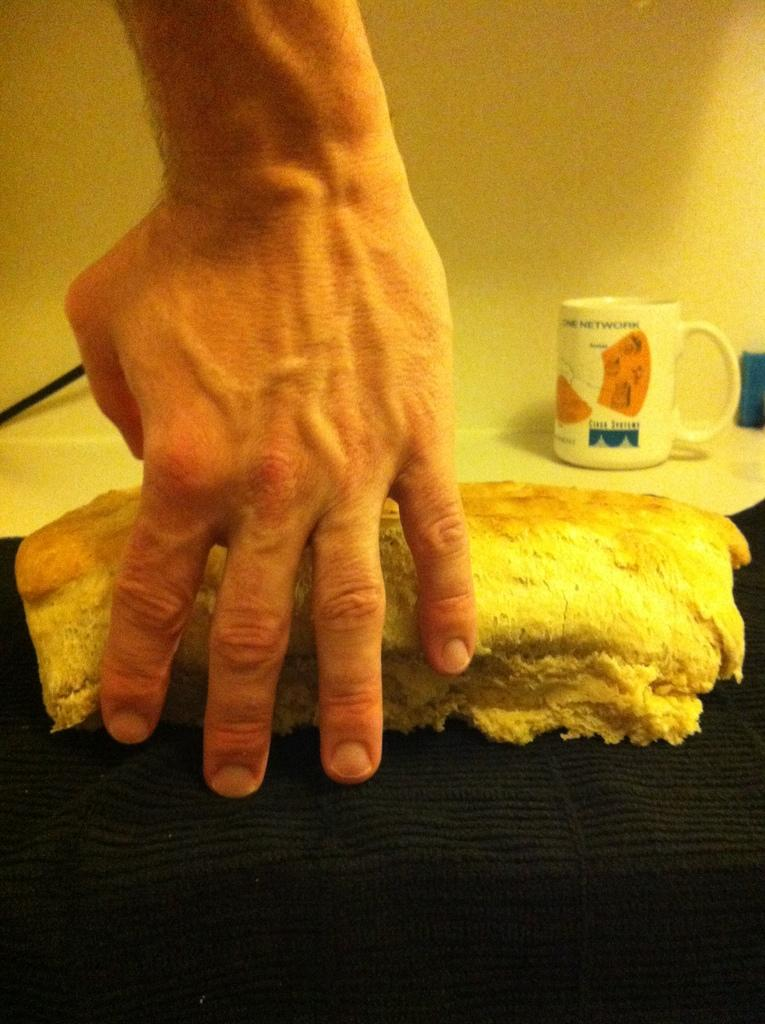What is the main subject of the image? There is a person in the image. What is the person holding in their hand? The person is holding food in their hand. Can you describe any other objects in the image? There is a cup on a table in the image. What can be seen in the background of the image? A wall is visible in the background of the image. What type of twig is the person using to eat the food in the image? There is no twig present in the image; the person is holding food in their hand. What type of suit is the person wearing in the image? The provided facts do not mention any clothing, so we cannot determine if the person is wearing a suit or any other type of clothing. 